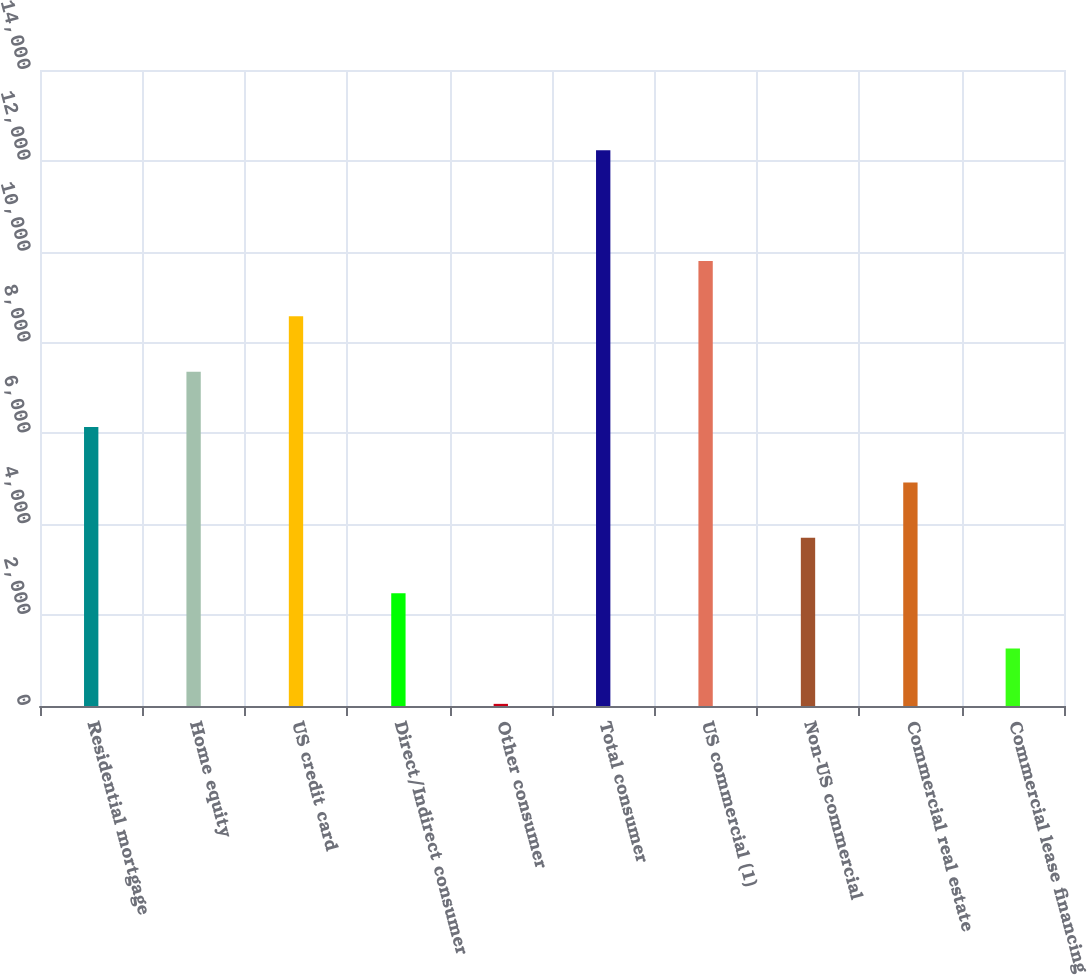Convert chart. <chart><loc_0><loc_0><loc_500><loc_500><bar_chart><fcel>Residential mortgage<fcel>Home equity<fcel>US credit card<fcel>Direct/Indirect consumer<fcel>Other consumer<fcel>Total consumer<fcel>US commercial (1)<fcel>Non-US commercial<fcel>Commercial real estate<fcel>Commercial lease financing<nl><fcel>6140.5<fcel>7359.2<fcel>8577.9<fcel>2484.4<fcel>47<fcel>12234<fcel>9796.6<fcel>3703.1<fcel>4921.8<fcel>1265.7<nl></chart> 